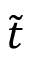Convert formula to latex. <formula><loc_0><loc_0><loc_500><loc_500>\tilde { t }</formula> 